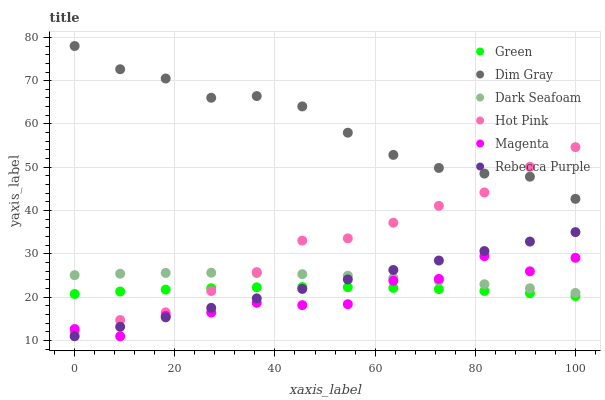Does Magenta have the minimum area under the curve?
Answer yes or no. Yes. Does Dim Gray have the maximum area under the curve?
Answer yes or no. Yes. Does Hot Pink have the minimum area under the curve?
Answer yes or no. No. Does Hot Pink have the maximum area under the curve?
Answer yes or no. No. Is Rebecca Purple the smoothest?
Answer yes or no. Yes. Is Magenta the roughest?
Answer yes or no. Yes. Is Hot Pink the smoothest?
Answer yes or no. No. Is Hot Pink the roughest?
Answer yes or no. No. Does Rebecca Purple have the lowest value?
Answer yes or no. Yes. Does Hot Pink have the lowest value?
Answer yes or no. No. Does Dim Gray have the highest value?
Answer yes or no. Yes. Does Hot Pink have the highest value?
Answer yes or no. No. Is Dark Seafoam less than Dim Gray?
Answer yes or no. Yes. Is Dim Gray greater than Rebecca Purple?
Answer yes or no. Yes. Does Magenta intersect Green?
Answer yes or no. Yes. Is Magenta less than Green?
Answer yes or no. No. Is Magenta greater than Green?
Answer yes or no. No. Does Dark Seafoam intersect Dim Gray?
Answer yes or no. No. 